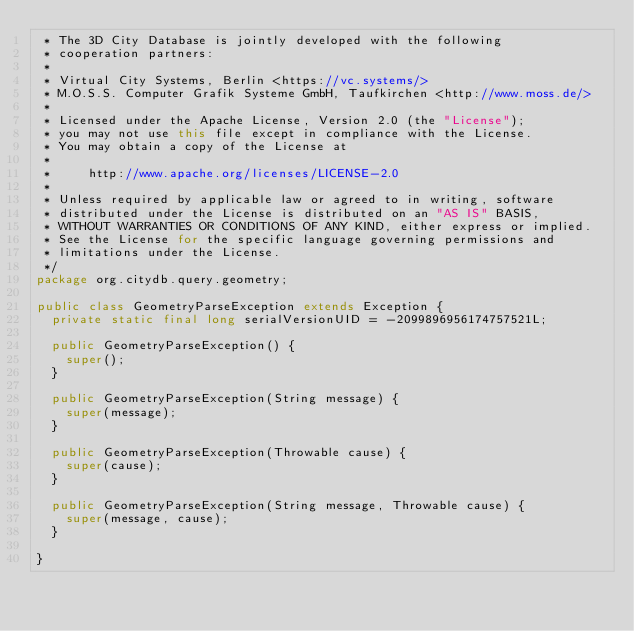Convert code to text. <code><loc_0><loc_0><loc_500><loc_500><_Java_> * The 3D City Database is jointly developed with the following
 * cooperation partners:
 *
 * Virtual City Systems, Berlin <https://vc.systems/>
 * M.O.S.S. Computer Grafik Systeme GmbH, Taufkirchen <http://www.moss.de/>
 *
 * Licensed under the Apache License, Version 2.0 (the "License");
 * you may not use this file except in compliance with the License.
 * You may obtain a copy of the License at
 *
 *     http://www.apache.org/licenses/LICENSE-2.0
 *
 * Unless required by applicable law or agreed to in writing, software
 * distributed under the License is distributed on an "AS IS" BASIS,
 * WITHOUT WARRANTIES OR CONDITIONS OF ANY KIND, either express or implied.
 * See the License for the specific language governing permissions and
 * limitations under the License.
 */
package org.citydb.query.geometry;

public class GeometryParseException extends Exception {
	private static final long serialVersionUID = -2099896956174757521L;

	public GeometryParseException() {
		super();
	}
	
	public GeometryParseException(String message) {
		super(message);
	}
	
	public GeometryParseException(Throwable cause) {
		super(cause);
	}
	
	public GeometryParseException(String message, Throwable cause) {
		super(message, cause);
	}
	
}
</code> 